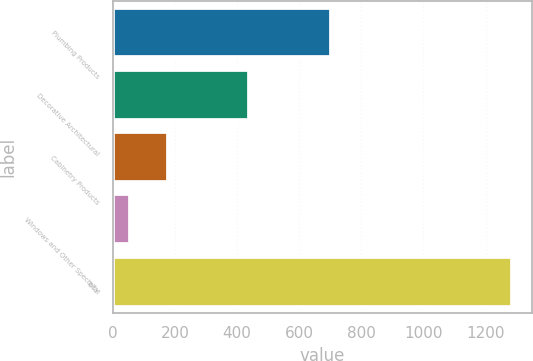<chart> <loc_0><loc_0><loc_500><loc_500><bar_chart><fcel>Plumbing Products<fcel>Decorative Architectural<fcel>Cabinetry Products<fcel>Windows and Other Specialty<fcel>Total<nl><fcel>702<fcel>438<fcel>177.2<fcel>54<fcel>1286<nl></chart> 